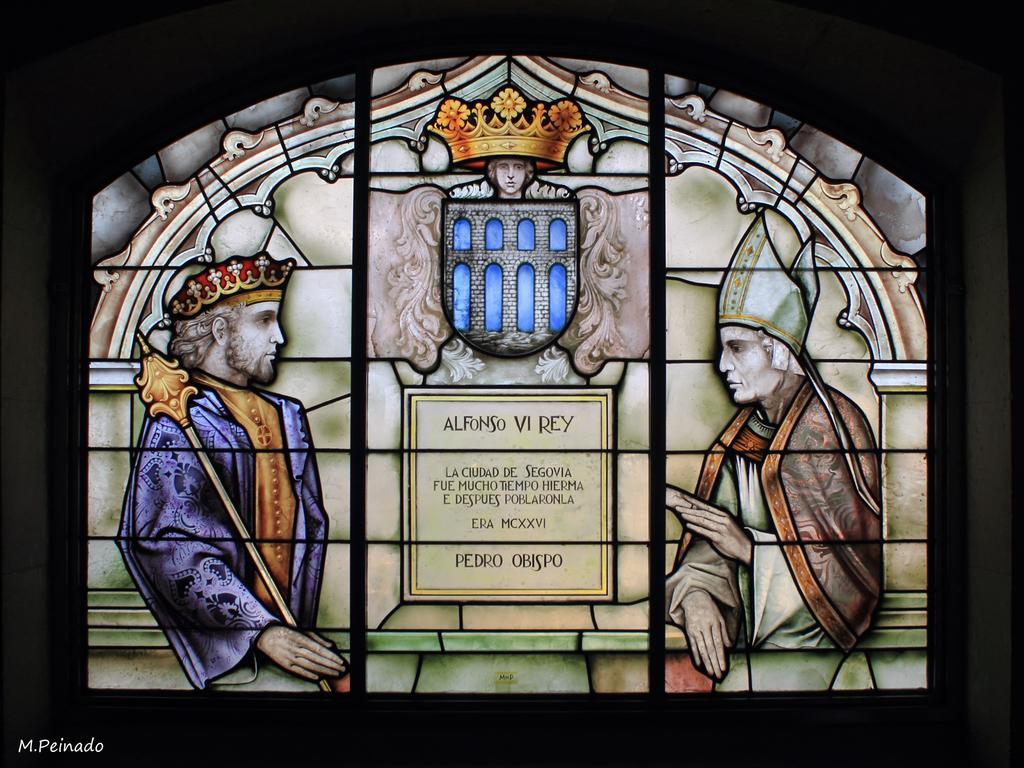How would you summarize this image in a sentence or two? In this we can see a tinted glass window. 